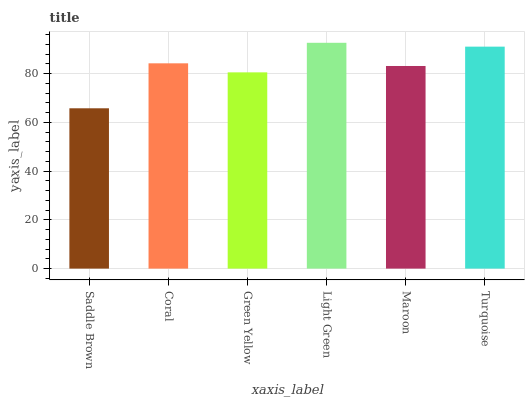Is Saddle Brown the minimum?
Answer yes or no. Yes. Is Light Green the maximum?
Answer yes or no. Yes. Is Coral the minimum?
Answer yes or no. No. Is Coral the maximum?
Answer yes or no. No. Is Coral greater than Saddle Brown?
Answer yes or no. Yes. Is Saddle Brown less than Coral?
Answer yes or no. Yes. Is Saddle Brown greater than Coral?
Answer yes or no. No. Is Coral less than Saddle Brown?
Answer yes or no. No. Is Coral the high median?
Answer yes or no. Yes. Is Maroon the low median?
Answer yes or no. Yes. Is Green Yellow the high median?
Answer yes or no. No. Is Green Yellow the low median?
Answer yes or no. No. 